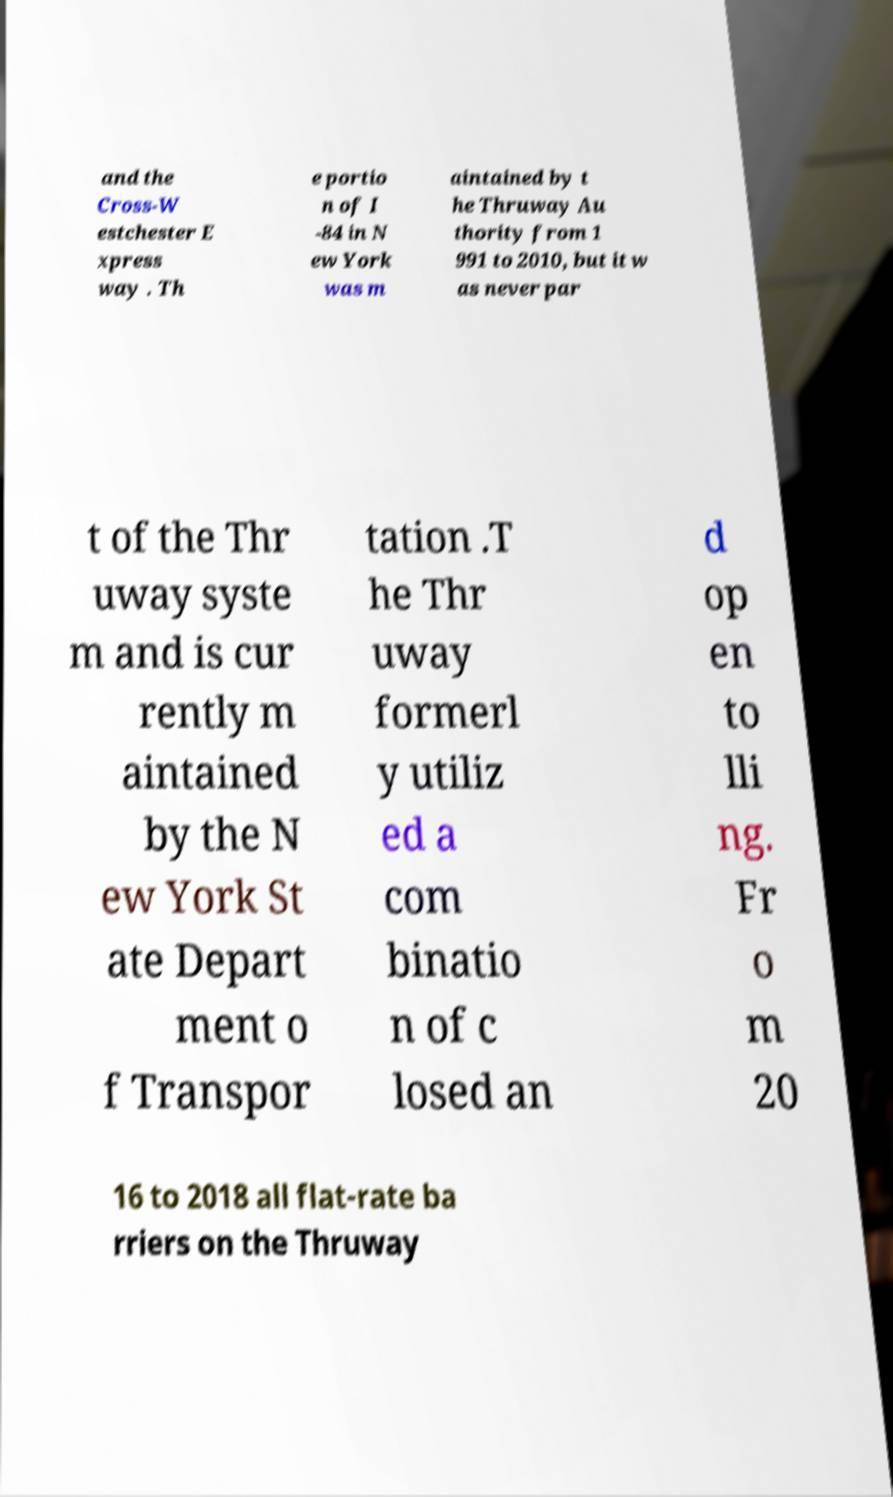For documentation purposes, I need the text within this image transcribed. Could you provide that? and the Cross-W estchester E xpress way . Th e portio n of I -84 in N ew York was m aintained by t he Thruway Au thority from 1 991 to 2010, but it w as never par t of the Thr uway syste m and is cur rently m aintained by the N ew York St ate Depart ment o f Transpor tation .T he Thr uway formerl y utiliz ed a com binatio n of c losed an d op en to lli ng. Fr o m 20 16 to 2018 all flat-rate ba rriers on the Thruway 